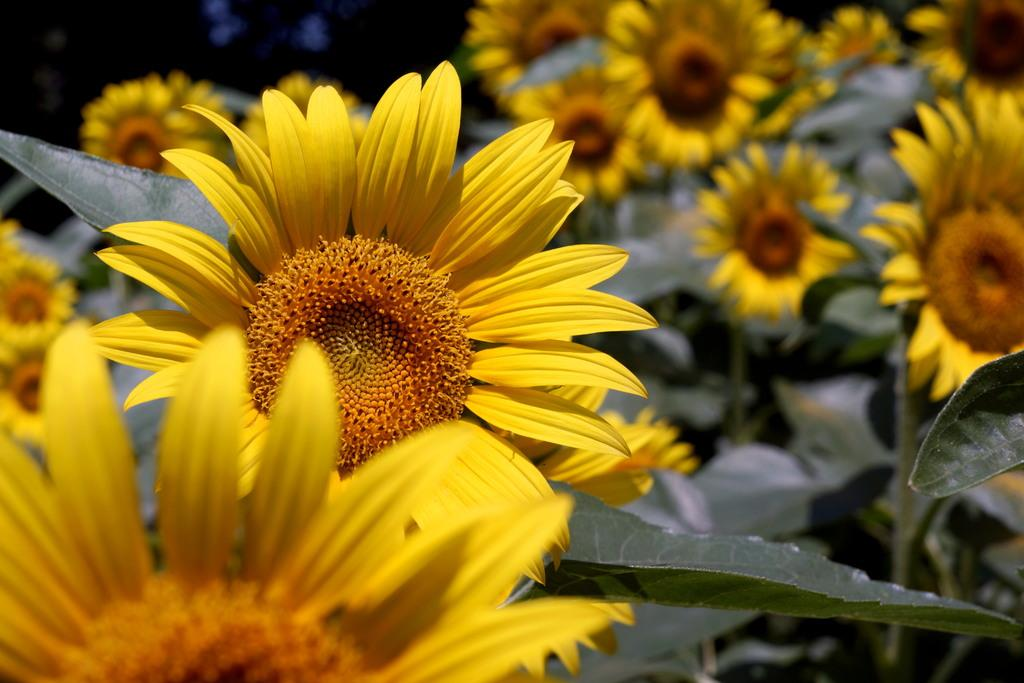What type of plants can be seen in the image? There are some plants with sunflowers in the image. How would you describe the background of the image? The background of the image is dark. What time does the clock show in the image? There is no clock present in the image. Can you see the sea in the background of the image? The image does not show the sea; it has a dark background with plants and sunflowers. 